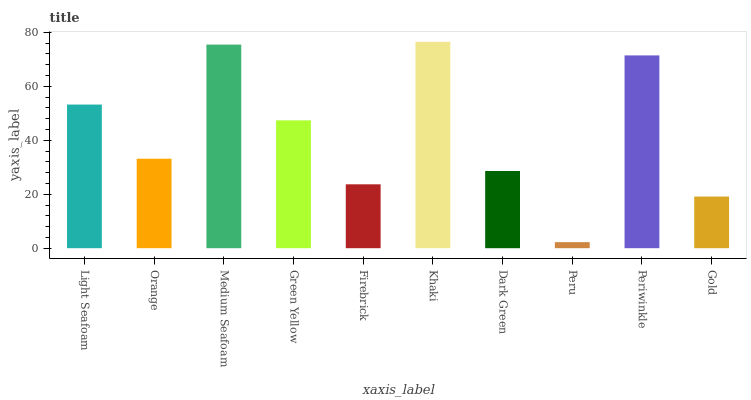Is Orange the minimum?
Answer yes or no. No. Is Orange the maximum?
Answer yes or no. No. Is Light Seafoam greater than Orange?
Answer yes or no. Yes. Is Orange less than Light Seafoam?
Answer yes or no. Yes. Is Orange greater than Light Seafoam?
Answer yes or no. No. Is Light Seafoam less than Orange?
Answer yes or no. No. Is Green Yellow the high median?
Answer yes or no. Yes. Is Orange the low median?
Answer yes or no. Yes. Is Peru the high median?
Answer yes or no. No. Is Firebrick the low median?
Answer yes or no. No. 